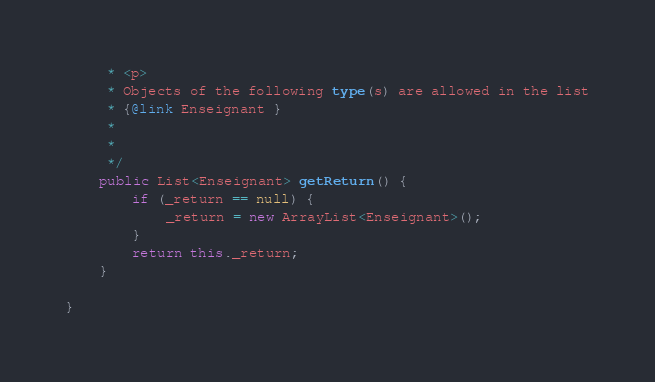<code> <loc_0><loc_0><loc_500><loc_500><_Java_>     * <p>
     * Objects of the following type(s) are allowed in the list
     * {@link Enseignant }
     *
     *
     */
    public List<Enseignant> getReturn() {
        if (_return == null) {
            _return = new ArrayList<Enseignant>();
        }
        return this._return;
    }

}
</code> 